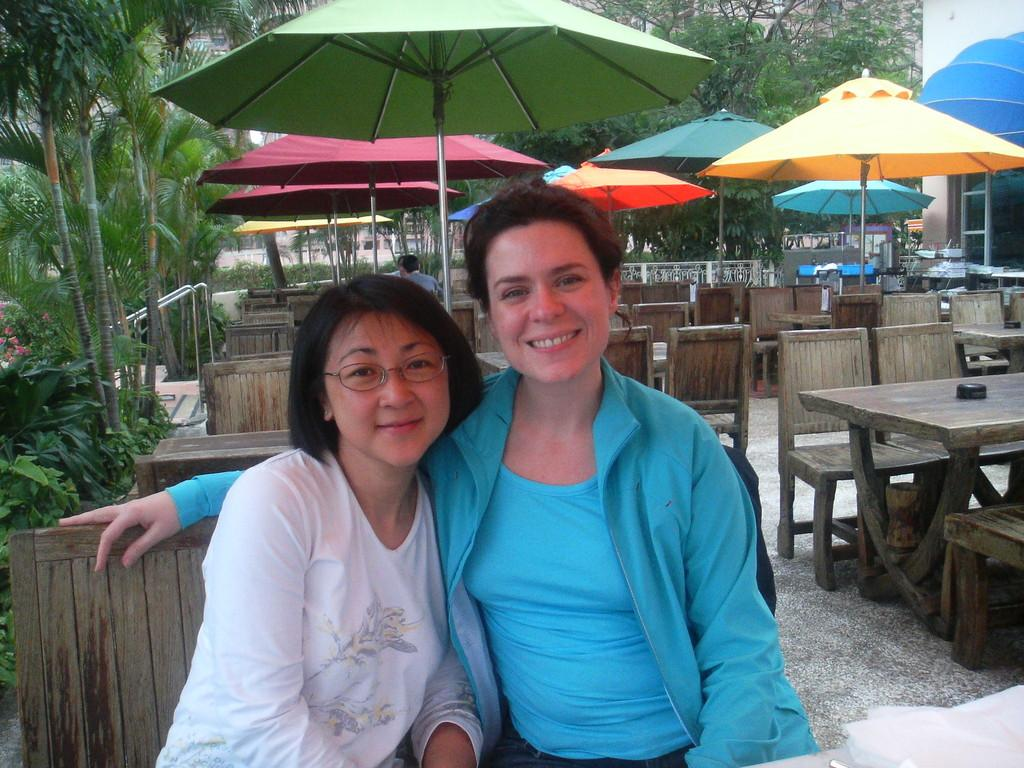How many people are in the image? There are two women in the image. What are the women doing in the image? The women are sitting on a bench. Can you describe the setting details be inferred from the image? Yes, the setting appears to be a hotel. What can be seen in the background of the image? There are many trees in the background of the image. What type of credit card is the woman on the left using in the image? There is no credit card or any indication of a transaction in the image. 